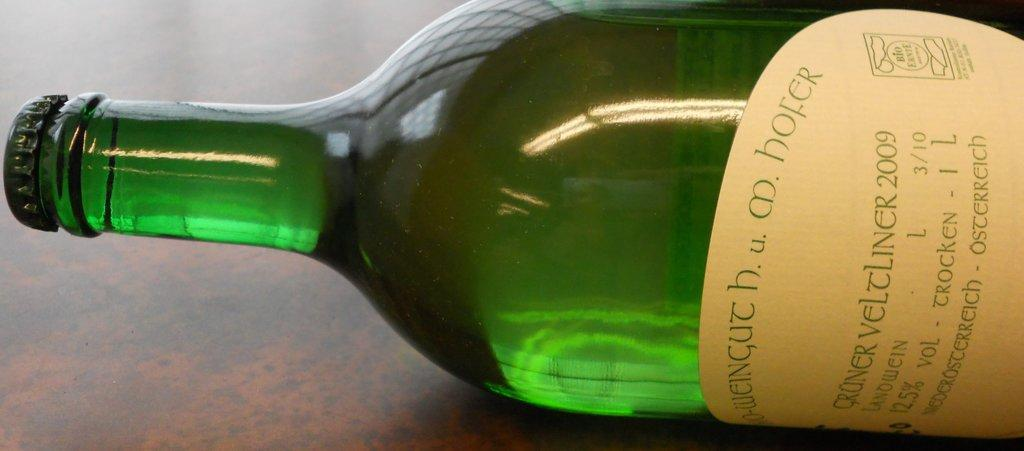<image>
Give a short and clear explanation of the subsequent image. A beige labeled green bottle of German wine. 